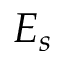Convert formula to latex. <formula><loc_0><loc_0><loc_500><loc_500>E _ { s }</formula> 